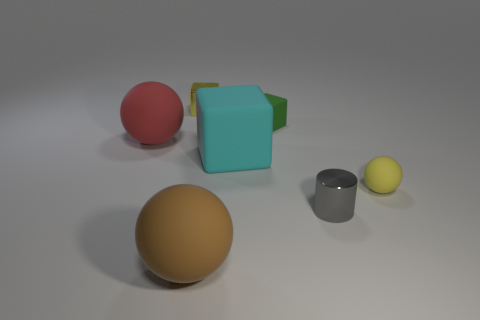Subtract all blocks. How many objects are left? 4 Add 3 brown matte spheres. How many objects exist? 10 Subtract all big cyan rubber blocks. How many blocks are left? 2 Subtract all red balls. How many balls are left? 2 Subtract 0 cyan cylinders. How many objects are left? 7 Subtract 1 cylinders. How many cylinders are left? 0 Subtract all yellow cylinders. Subtract all brown blocks. How many cylinders are left? 1 Subtract all red cylinders. How many red balls are left? 1 Subtract all small cyan metal cubes. Subtract all small gray objects. How many objects are left? 6 Add 1 cyan matte things. How many cyan matte things are left? 2 